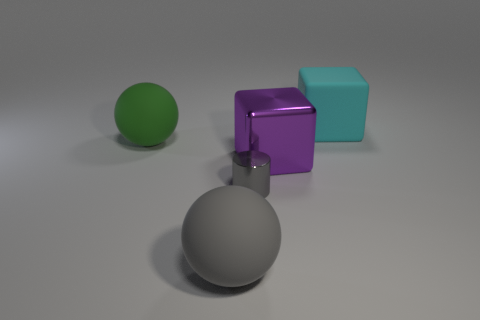What shape is the object that is left of the big rubber sphere that is in front of the metallic object that is behind the tiny gray cylinder?
Your answer should be compact. Sphere. Are there more cylinders than blue objects?
Provide a short and direct response. Yes. Are any big purple cubes visible?
Offer a very short reply. Yes. What number of objects are gray things that are right of the large gray object or big matte things that are to the left of the small metallic cylinder?
Ensure brevity in your answer.  3. Does the metal cylinder have the same color as the metallic block?
Your response must be concise. No. Is the number of rubber things less than the number of small red rubber things?
Your answer should be compact. No. There is a cylinder; are there any cyan blocks in front of it?
Provide a succinct answer. No. Do the purple thing and the big cyan object have the same material?
Offer a terse response. No. There is another rubber thing that is the same shape as the large green thing; what is its color?
Provide a short and direct response. Gray. There is a big cube that is behind the green matte ball; is its color the same as the metallic cylinder?
Provide a succinct answer. No. 